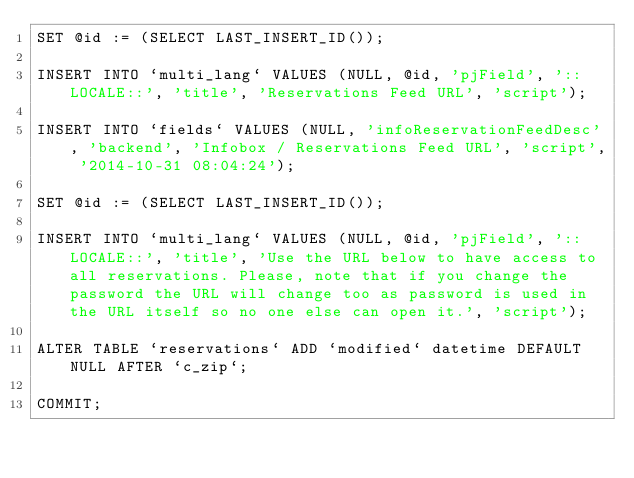Convert code to text. <code><loc_0><loc_0><loc_500><loc_500><_SQL_>SET @id := (SELECT LAST_INSERT_ID());

INSERT INTO `multi_lang` VALUES (NULL, @id, 'pjField', '::LOCALE::', 'title', 'Reservations Feed URL', 'script');

INSERT INTO `fields` VALUES (NULL, 'infoReservationFeedDesc', 'backend', 'Infobox / Reservations Feed URL', 'script', '2014-10-31 08:04:24');

SET @id := (SELECT LAST_INSERT_ID());

INSERT INTO `multi_lang` VALUES (NULL, @id, 'pjField', '::LOCALE::', 'title', 'Use the URL below to have access to all reservations. Please, note that if you change the password the URL will change too as password is used in the URL itself so no one else can open it.', 'script');

ALTER TABLE `reservations` ADD `modified` datetime DEFAULT NULL AFTER `c_zip`;

COMMIT;</code> 